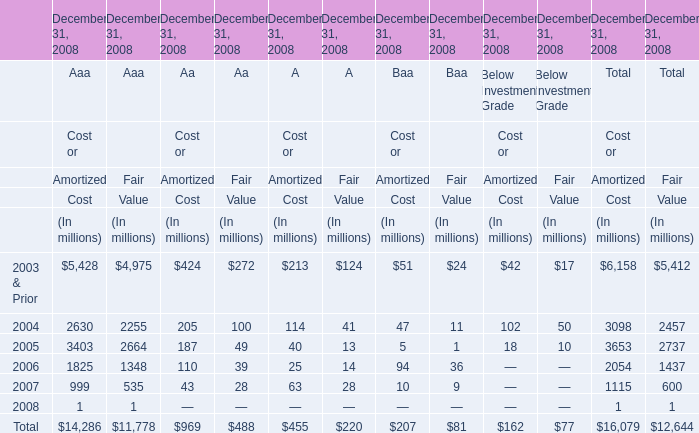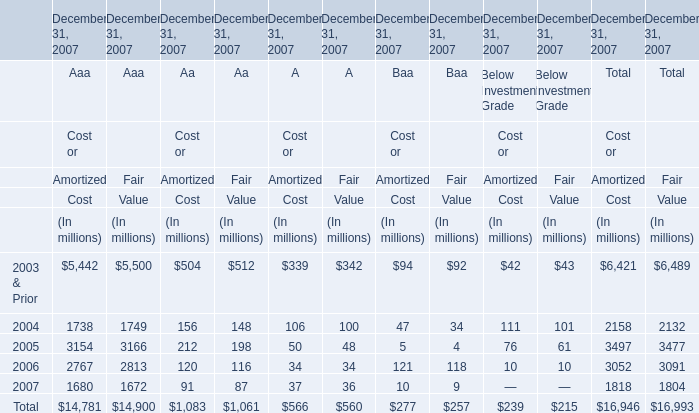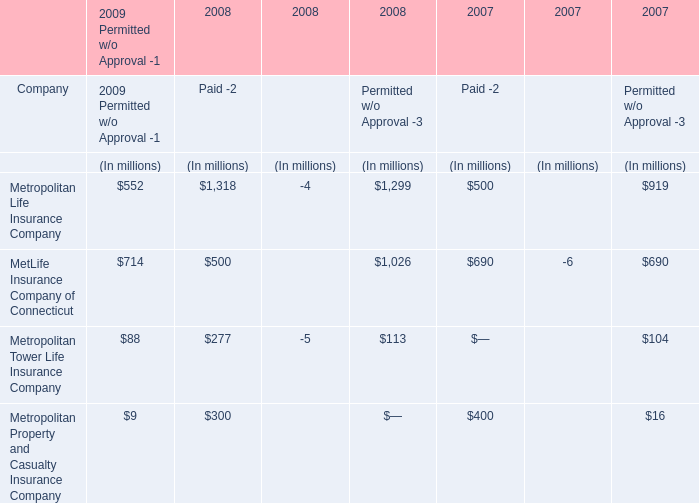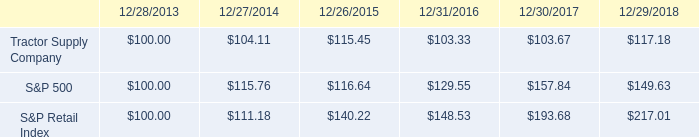What is the difference between the greatest Aaa in 2003 and 2004 for cost? (in million) 
Computations: (5428 - 2630)
Answer: 2798.0. 